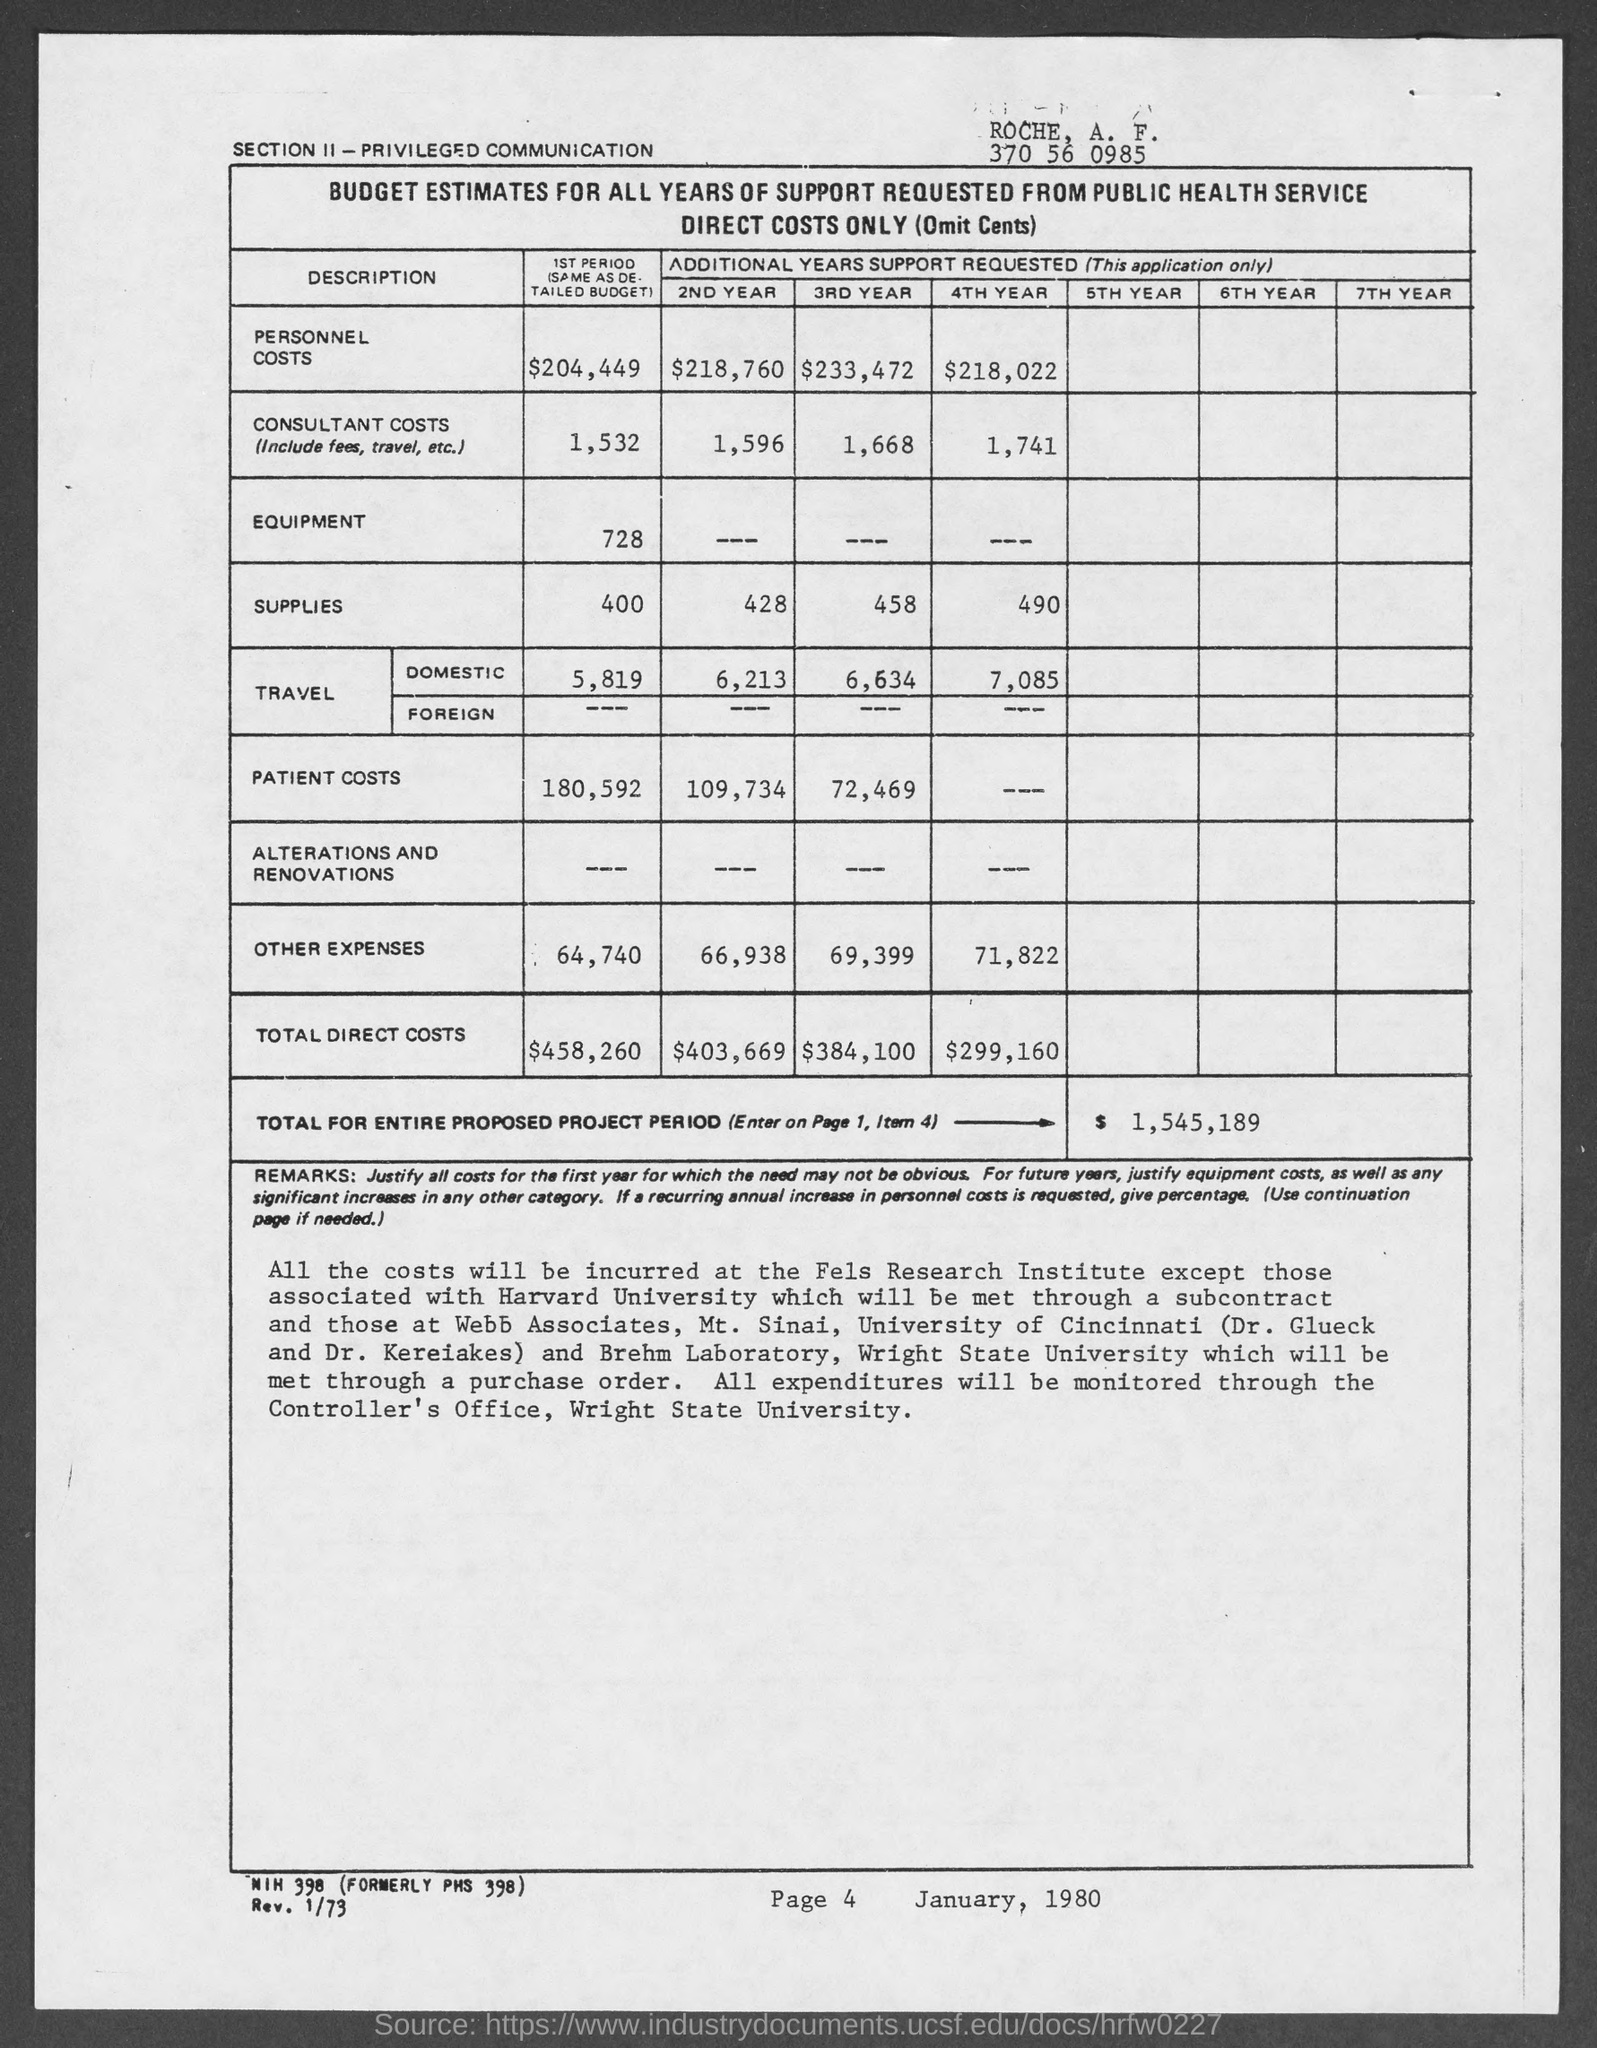What is total for entire proposed project period?
Your response must be concise. $ 1,545,189. 